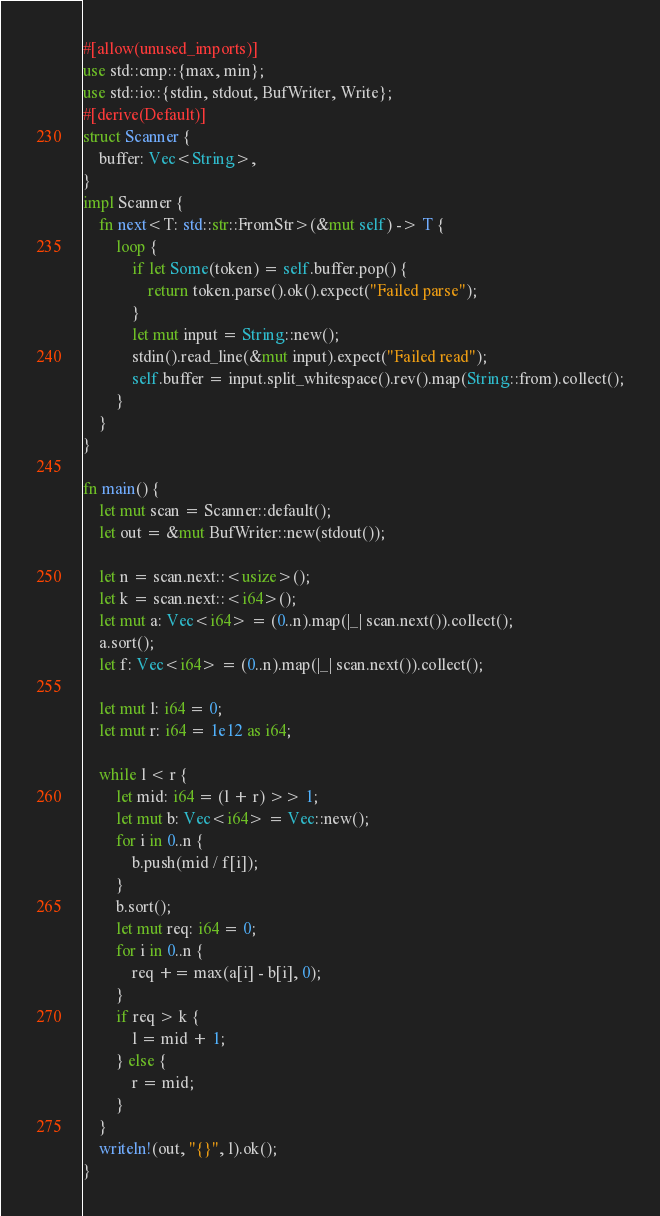<code> <loc_0><loc_0><loc_500><loc_500><_Rust_>#[allow(unused_imports)]
use std::cmp::{max, min};
use std::io::{stdin, stdout, BufWriter, Write};
#[derive(Default)]
struct Scanner {
    buffer: Vec<String>,
}
impl Scanner {
    fn next<T: std::str::FromStr>(&mut self) -> T {
        loop {
            if let Some(token) = self.buffer.pop() {
                return token.parse().ok().expect("Failed parse");
            }
            let mut input = String::new();
            stdin().read_line(&mut input).expect("Failed read");
            self.buffer = input.split_whitespace().rev().map(String::from).collect();
        }
    }
}

fn main() {
    let mut scan = Scanner::default();
    let out = &mut BufWriter::new(stdout());

    let n = scan.next::<usize>();
    let k = scan.next::<i64>();
    let mut a: Vec<i64> = (0..n).map(|_| scan.next()).collect();
    a.sort();
    let f: Vec<i64> = (0..n).map(|_| scan.next()).collect();

    let mut l: i64 = 0;
    let mut r: i64 = 1e12 as i64;

    while l < r {
        let mid: i64 = (l + r) >> 1;
        let mut b: Vec<i64> = Vec::new();
        for i in 0..n {
            b.push(mid / f[i]);
        }
        b.sort();
        let mut req: i64 = 0;
        for i in 0..n {
            req += max(a[i] - b[i], 0);
        }
        if req > k {
            l = mid + 1;
        } else {
            r = mid;
        }
    }
    writeln!(out, "{}", l).ok();
}
</code> 